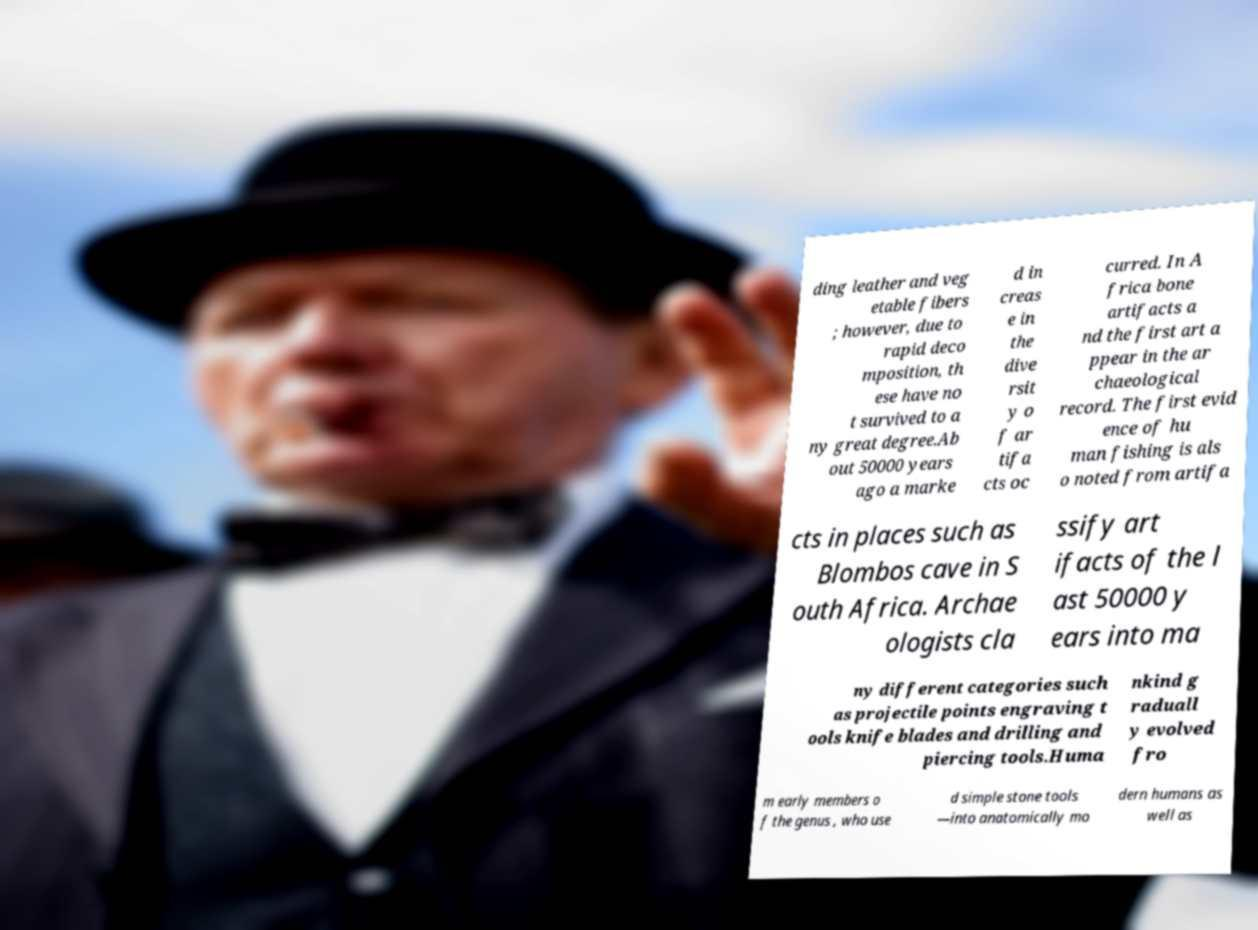Can you read and provide the text displayed in the image?This photo seems to have some interesting text. Can you extract and type it out for me? ding leather and veg etable fibers ; however, due to rapid deco mposition, th ese have no t survived to a ny great degree.Ab out 50000 years ago a marke d in creas e in the dive rsit y o f ar tifa cts oc curred. In A frica bone artifacts a nd the first art a ppear in the ar chaeological record. The first evid ence of hu man fishing is als o noted from artifa cts in places such as Blombos cave in S outh Africa. Archae ologists cla ssify art ifacts of the l ast 50000 y ears into ma ny different categories such as projectile points engraving t ools knife blades and drilling and piercing tools.Huma nkind g raduall y evolved fro m early members o f the genus , who use d simple stone tools —into anatomically mo dern humans as well as 